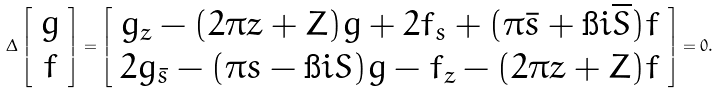Convert formula to latex. <formula><loc_0><loc_0><loc_500><loc_500>\Delta \left [ \begin{array} { c } g \\ f \end{array} \right ] = \left [ \begin{array} { c } g _ { z } - ( 2 \pi z + Z ) g + 2 f _ { s } + ( \pi { \bar { s } } + \i i \overline { S } ) f \\ 2 g _ { \bar { s } } - ( \pi s - \i i S ) g - f _ { z } - ( 2 \pi z + Z ) f \end{array} \right ] = 0 .</formula> 